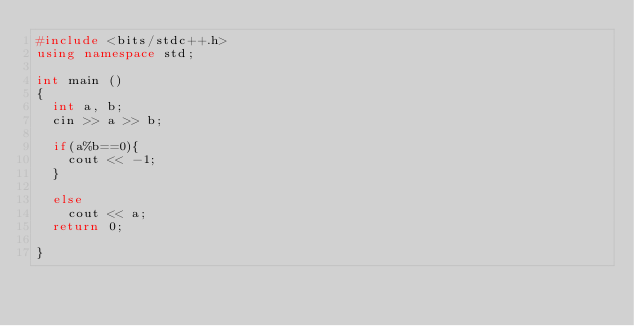Convert code to text. <code><loc_0><loc_0><loc_500><loc_500><_C++_>#include <bits/stdc++.h>
using namespace std;

int main ()
{
	int a, b;
	cin >> a >> b;

	if(a%b==0){
		cout << -1;
	}
	
	else
		cout << a;
	return 0;

}</code> 